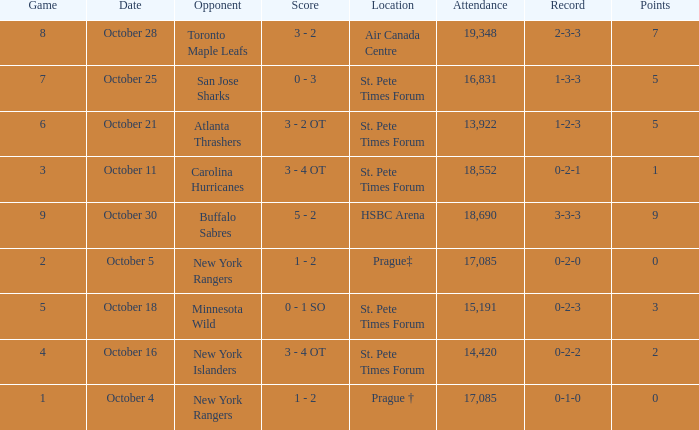What was the attendance when their record stood at 0-2-2? 14420.0. 